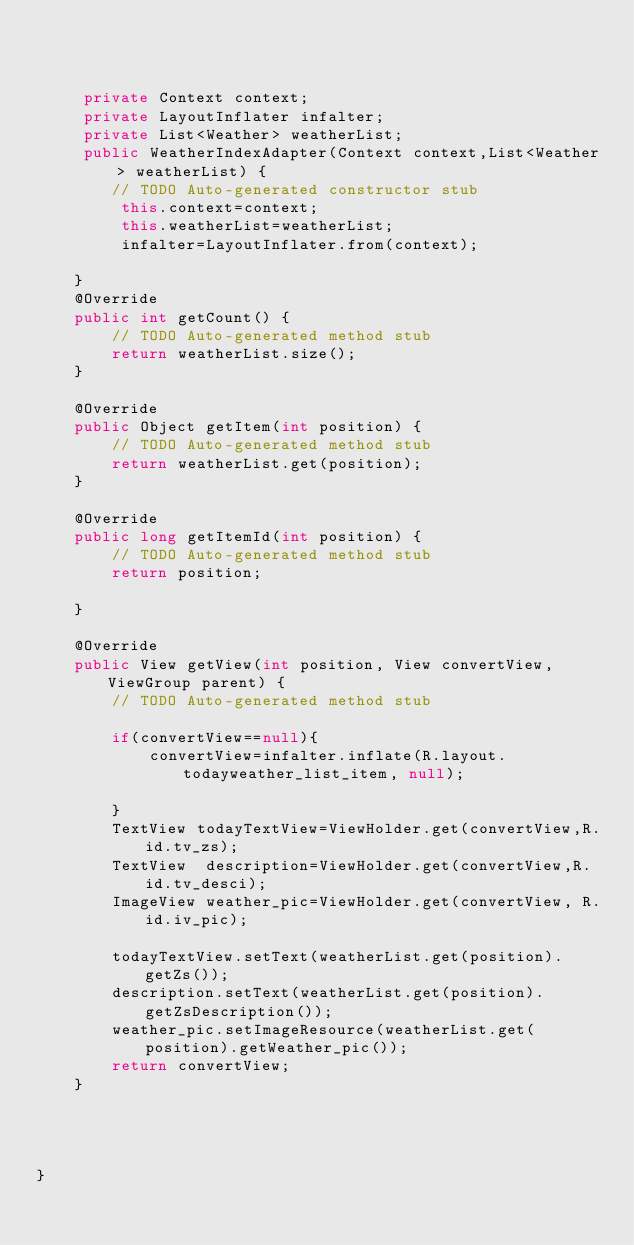<code> <loc_0><loc_0><loc_500><loc_500><_Java_>    
	
	
	 private Context context;
	 private LayoutInflater infalter;
	 private List<Weather> weatherList;
	 public WeatherIndexAdapter(Context context,List<Weather> weatherList) {
		// TODO Auto-generated constructor stub
		 this.context=context;
		 this.weatherList=weatherList;
		 infalter=LayoutInflater.from(context);
		 
	}
	@Override
	public int getCount() {
		// TODO Auto-generated method stub
		return weatherList.size();
	}

	@Override
	public Object getItem(int position) {
		// TODO Auto-generated method stub
		return weatherList.get(position);
	}

	@Override
	public long getItemId(int position) {
		// TODO Auto-generated method stub
		return position;
		
	}

	@Override
	public View getView(int position, View convertView, ViewGroup parent) {
		// TODO Auto-generated method stub
		
		if(convertView==null){
			convertView=infalter.inflate(R.layout.todayweather_list_item, null);

		}
	    TextView todayTextView=ViewHolder.get(convertView,R.id.tv_zs);
	    TextView  description=ViewHolder.get(convertView,R.id.tv_desci);
	    ImageView weather_pic=ViewHolder.get(convertView, R.id.iv_pic);
	  
	    todayTextView.setText(weatherList.get(position).getZs());
	    description.setText(weatherList.get(position).getZsDescription());
	    weather_pic.setImageResource(weatherList.get(position).getWeather_pic());
		return convertView;
	}
	
	
	

}
</code> 